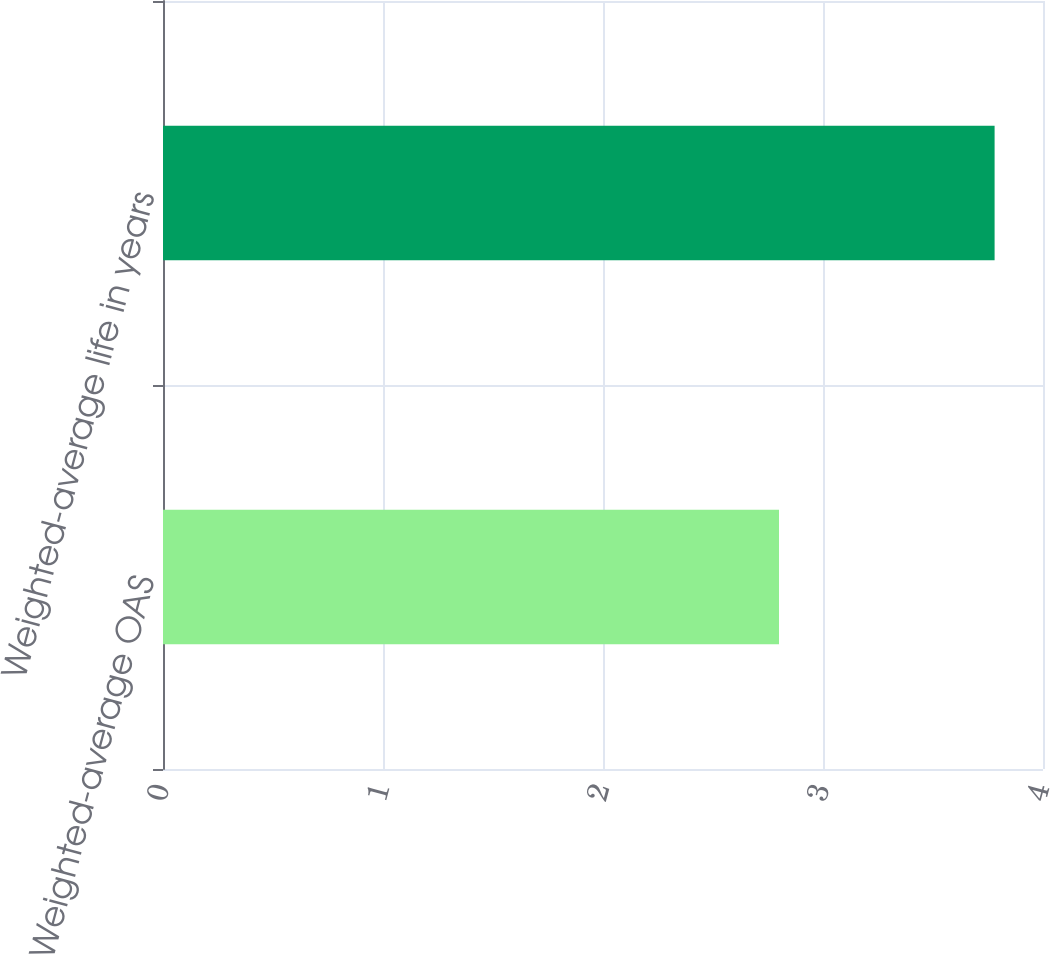Convert chart to OTSL. <chart><loc_0><loc_0><loc_500><loc_500><bar_chart><fcel>Weighted-average OAS<fcel>Weighted-average life in years<nl><fcel>2.8<fcel>3.78<nl></chart> 